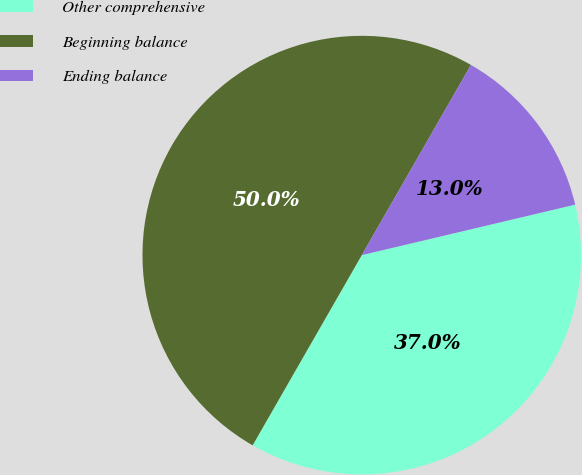<chart> <loc_0><loc_0><loc_500><loc_500><pie_chart><fcel>Other comprehensive<fcel>Beginning balance<fcel>Ending balance<nl><fcel>36.99%<fcel>50.0%<fcel>13.01%<nl></chart> 